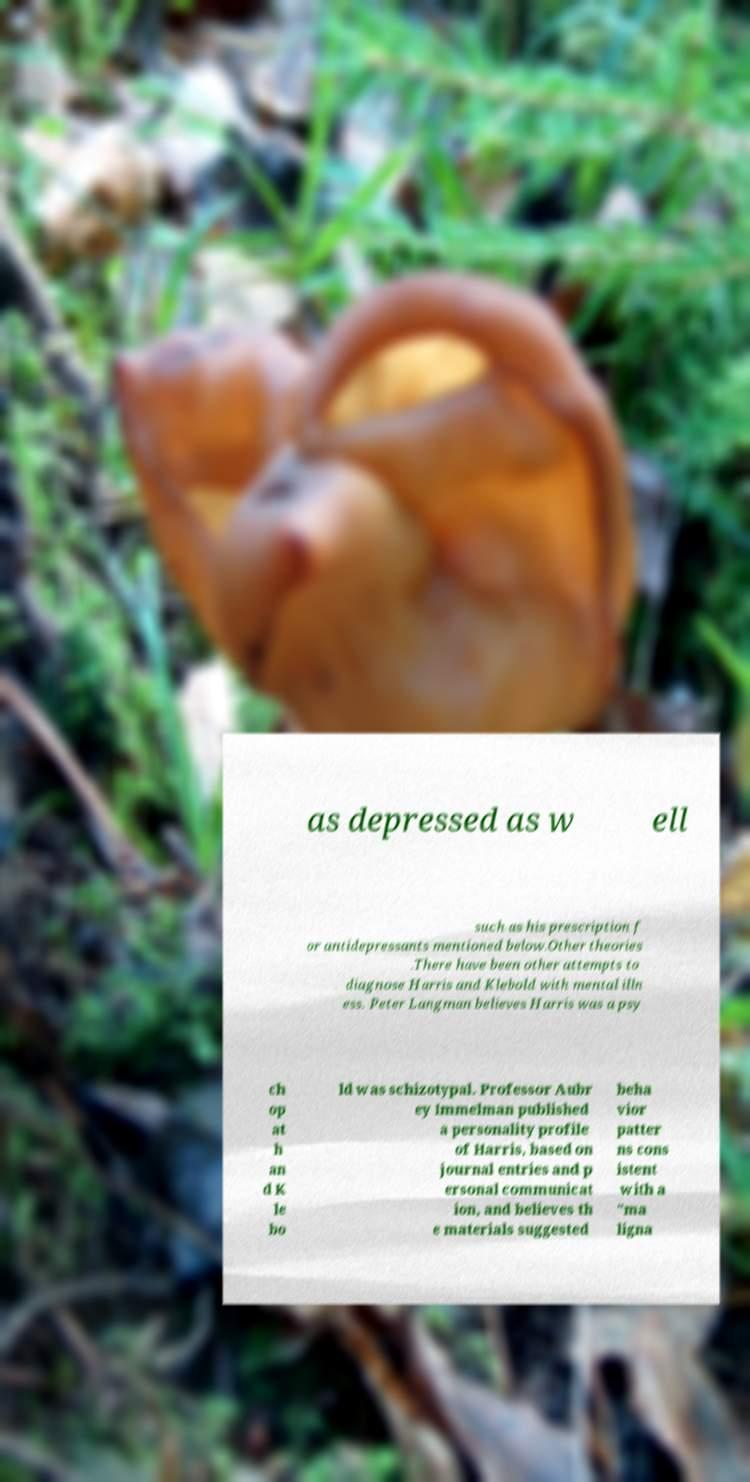Can you read and provide the text displayed in the image?This photo seems to have some interesting text. Can you extract and type it out for me? as depressed as w ell such as his prescription f or antidepressants mentioned below.Other theories .There have been other attempts to diagnose Harris and Klebold with mental illn ess. Peter Langman believes Harris was a psy ch op at h an d K le bo ld was schizotypal. Professor Aubr ey Immelman published a personality profile of Harris, based on journal entries and p ersonal communicat ion, and believes th e materials suggested beha vior patter ns cons istent with a "ma ligna 